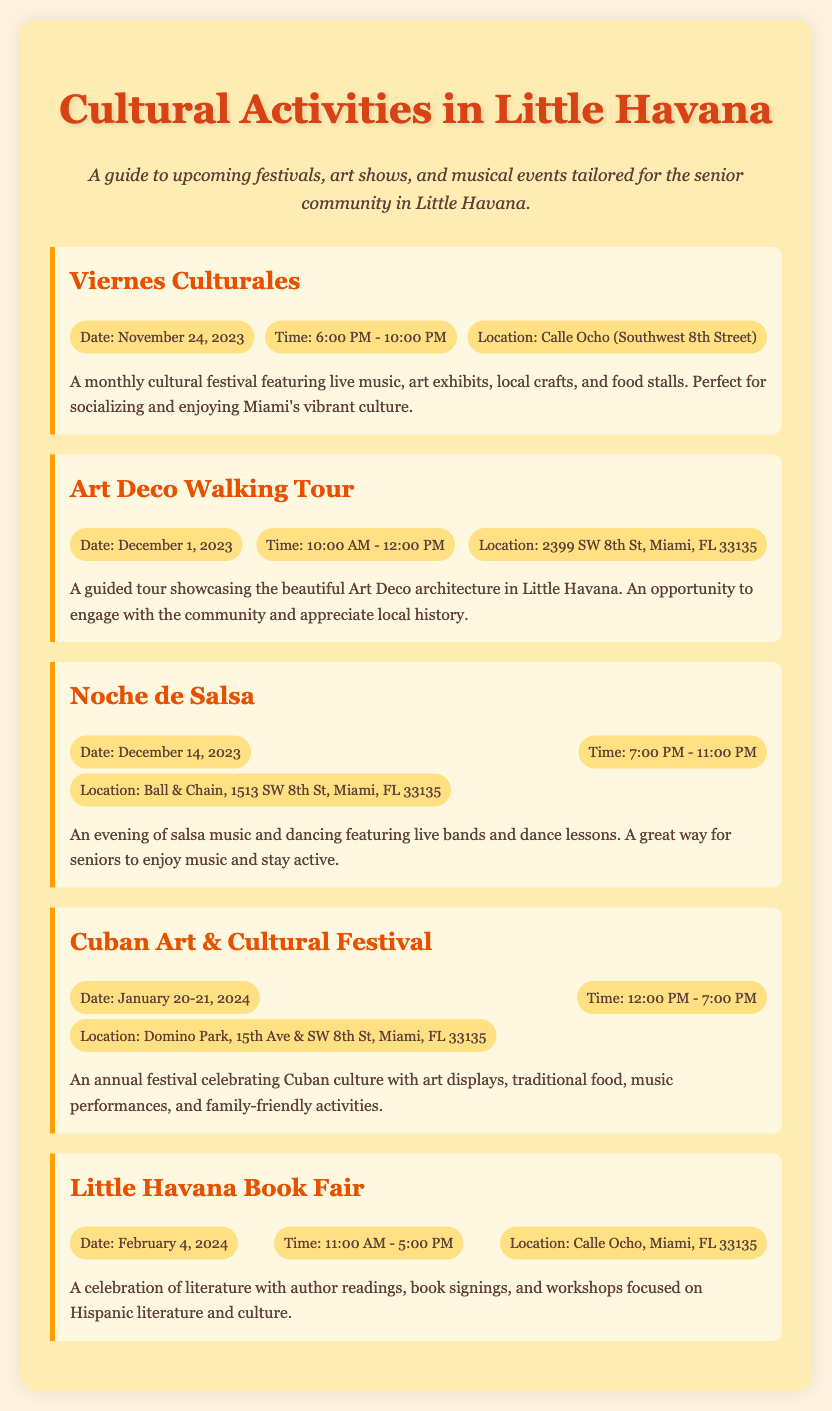What is the title of the first event? The title of the first event listed in the document is mentioned at the beginning of its section.
Answer: Viernes Culturales What is the date of the Cuban Art & Cultural Festival? The date of this festival is specified in the event details within the document.
Answer: January 20-21, 2024 Where is the Little Havana Book Fair taking place? The location is provided in the event details for the Little Havana Book Fair.
Answer: Calle Ocho, Miami, FL 33135 What time does Noche de Salsa start? The start time for Noche de Salsa is clearly mentioned in the event details.
Answer: 7:00 PM How many events are listed in the document? The number of events is counted by the different sections in the document.
Answer: 5 What type of event is the Art Deco Walking Tour? This event is characterized by being a guided tour focused on local architecture, as described in the document.
Answer: Guided tour Which event features live music and dance lessons? This information is derived from the description of the event that focuses on dancing and music.
Answer: Noche de Salsa What is the time duration of the Cuban Art & Cultural Festival? The duration is determined by the provided starting and ending times in the event details.
Answer: 7 hours 